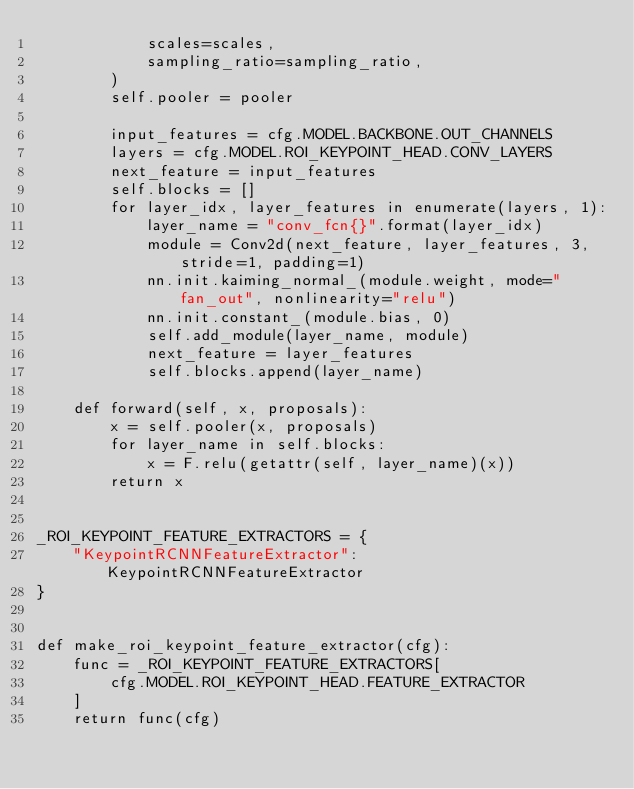<code> <loc_0><loc_0><loc_500><loc_500><_Python_>            scales=scales,
            sampling_ratio=sampling_ratio,
        )
        self.pooler = pooler

        input_features = cfg.MODEL.BACKBONE.OUT_CHANNELS
        layers = cfg.MODEL.ROI_KEYPOINT_HEAD.CONV_LAYERS
        next_feature = input_features
        self.blocks = []
        for layer_idx, layer_features in enumerate(layers, 1):
            layer_name = "conv_fcn{}".format(layer_idx)
            module = Conv2d(next_feature, layer_features, 3, stride=1, padding=1)
            nn.init.kaiming_normal_(module.weight, mode="fan_out", nonlinearity="relu")
            nn.init.constant_(module.bias, 0)
            self.add_module(layer_name, module)
            next_feature = layer_features
            self.blocks.append(layer_name)

    def forward(self, x, proposals):
        x = self.pooler(x, proposals)
        for layer_name in self.blocks:
            x = F.relu(getattr(self, layer_name)(x))
        return x


_ROI_KEYPOINT_FEATURE_EXTRACTORS = {
    "KeypointRCNNFeatureExtractor": KeypointRCNNFeatureExtractor
}


def make_roi_keypoint_feature_extractor(cfg):
    func = _ROI_KEYPOINT_FEATURE_EXTRACTORS[
        cfg.MODEL.ROI_KEYPOINT_HEAD.FEATURE_EXTRACTOR
    ]
    return func(cfg)
</code> 